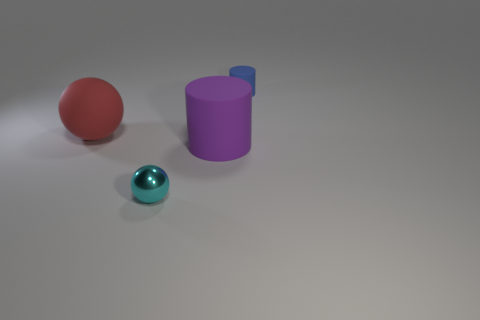Add 1 tiny blue cubes. How many objects exist? 5 Subtract all red spheres. How many spheres are left? 1 Subtract 1 balls. How many balls are left? 1 Add 3 big red cylinders. How many big red cylinders exist? 3 Subtract 0 green cubes. How many objects are left? 4 Subtract all blue cylinders. Subtract all blue cubes. How many cylinders are left? 1 Subtract all red blocks. How many red balls are left? 1 Subtract all tiny purple metal cylinders. Subtract all small cyan balls. How many objects are left? 3 Add 2 cylinders. How many cylinders are left? 4 